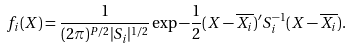<formula> <loc_0><loc_0><loc_500><loc_500>f _ { i } ( X ) = \frac { 1 } { ( 2 \pi ) ^ { P / 2 } | S _ { i } | ^ { 1 / 2 } } \exp { - \frac { 1 } { 2 } ( X - \overline { X _ { i } } ) ^ { \prime } S _ { i } ^ { - 1 } ( X - \overline { X _ { i } } ) } .</formula> 